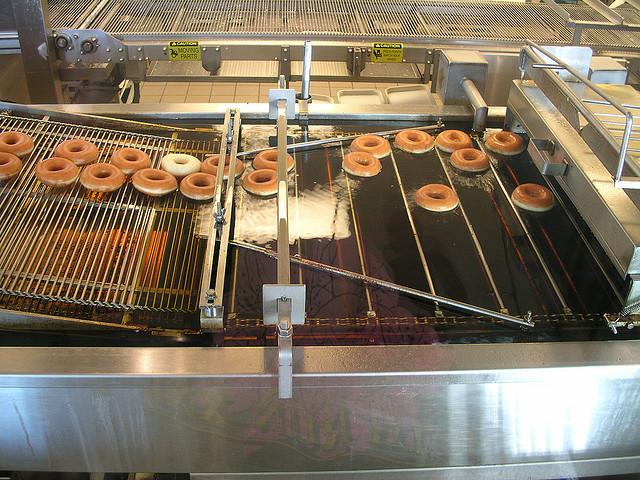What is this type of cooking called?

Choices:
A) vegan
B) handmade
C) fat-free
D) production line production line 